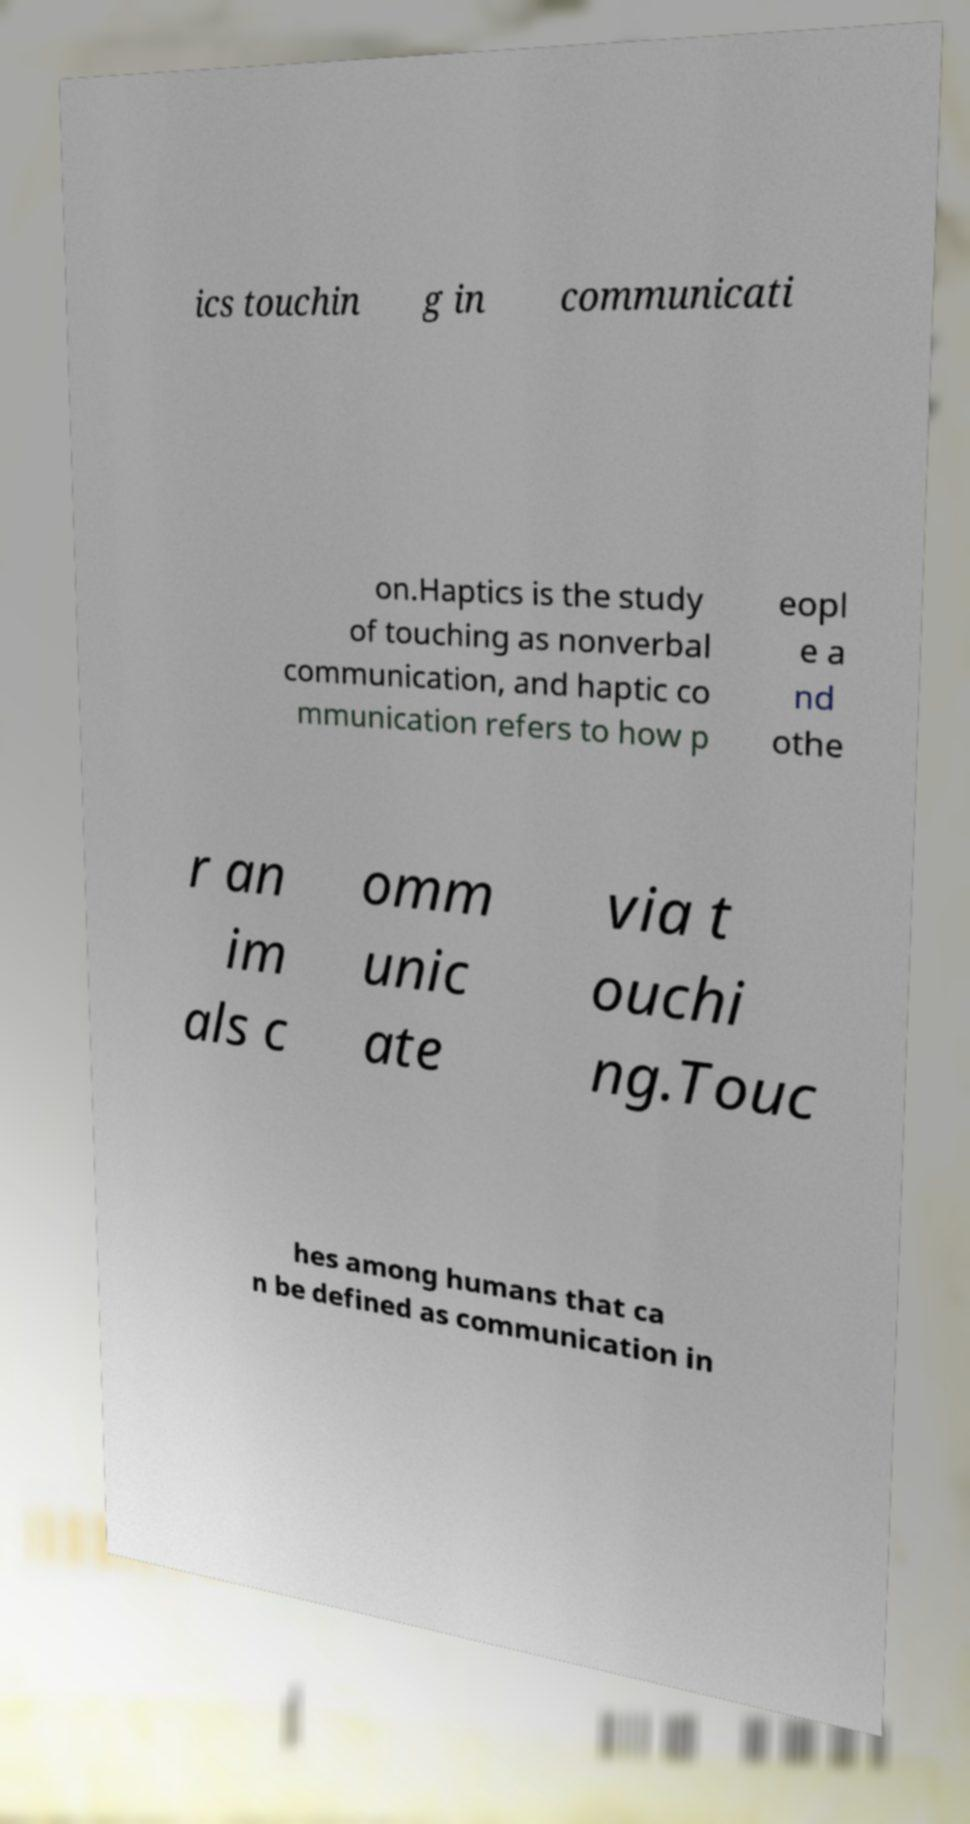There's text embedded in this image that I need extracted. Can you transcribe it verbatim? ics touchin g in communicati on.Haptics is the study of touching as nonverbal communication, and haptic co mmunication refers to how p eopl e a nd othe r an im als c omm unic ate via t ouchi ng.Touc hes among humans that ca n be defined as communication in 